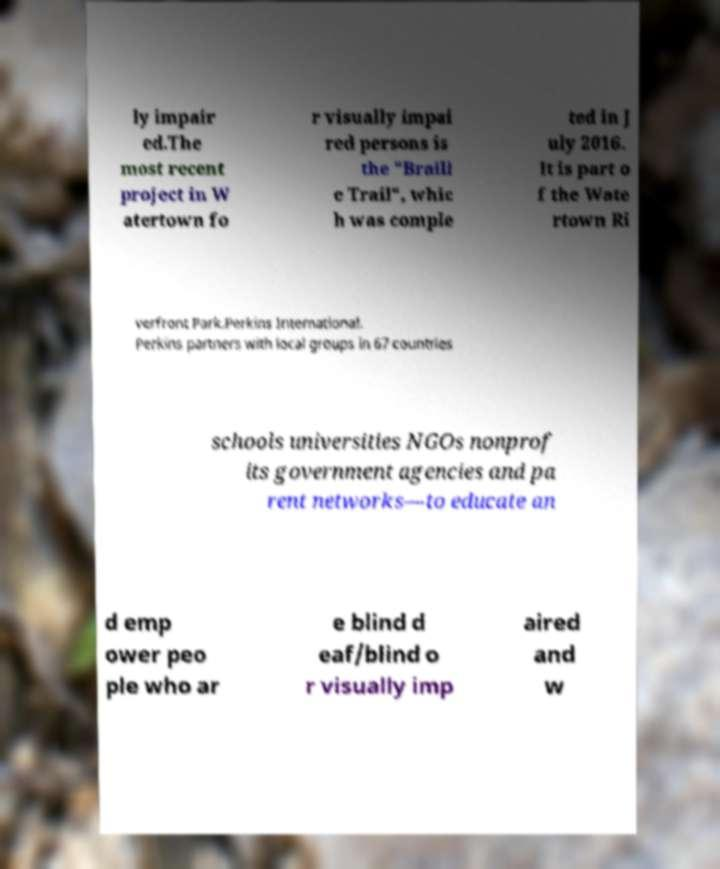There's text embedded in this image that I need extracted. Can you transcribe it verbatim? ly impair ed.The most recent project in W atertown fo r visually impai red persons is the "Braill e Trail", whic h was comple ted in J uly 2016. It is part o f the Wate rtown Ri verfront Park.Perkins International. Perkins partners with local groups in 67 countries schools universities NGOs nonprof its government agencies and pa rent networks—to educate an d emp ower peo ple who ar e blind d eaf/blind o r visually imp aired and w 